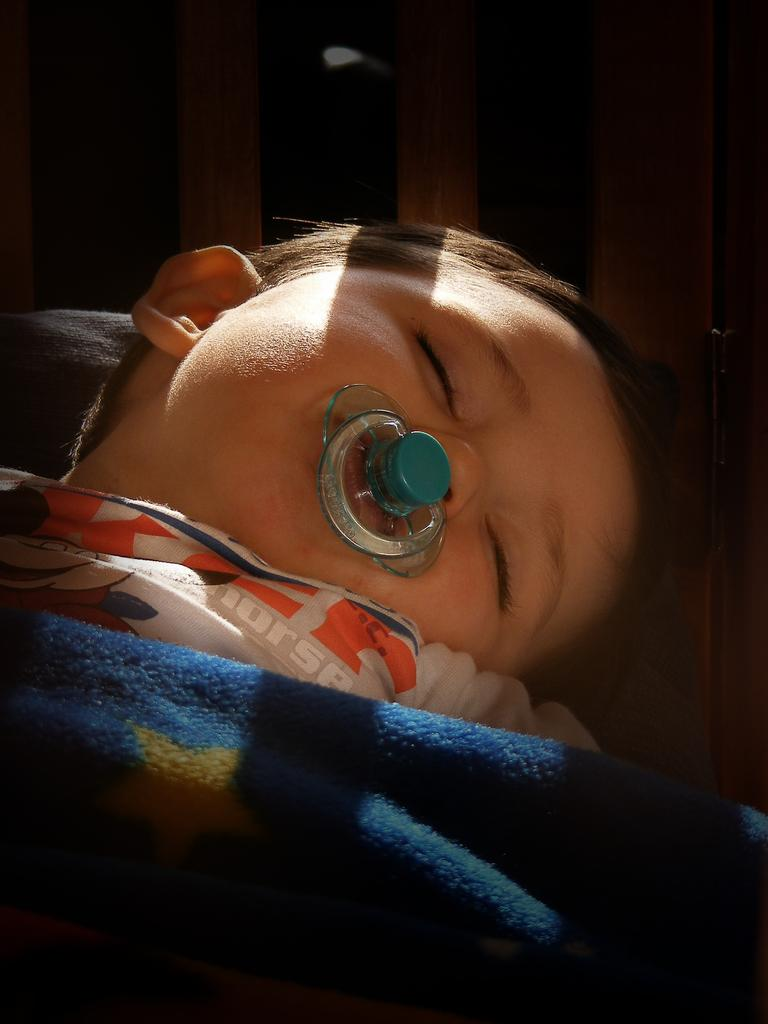What is the main subject of the image? The main subject of the image is a kid. What is covering the kid in the image? The kid is covered by a blanket. What is the kid doing in the image? The kid is sleeping. What is the condition of the son in the image? The provided facts do not mention a son, so we cannot determine the condition of a son in the image. What is the mom doing in the image? The provided facts do not mention a mom, so we cannot determine what the mom is doing in the image. 